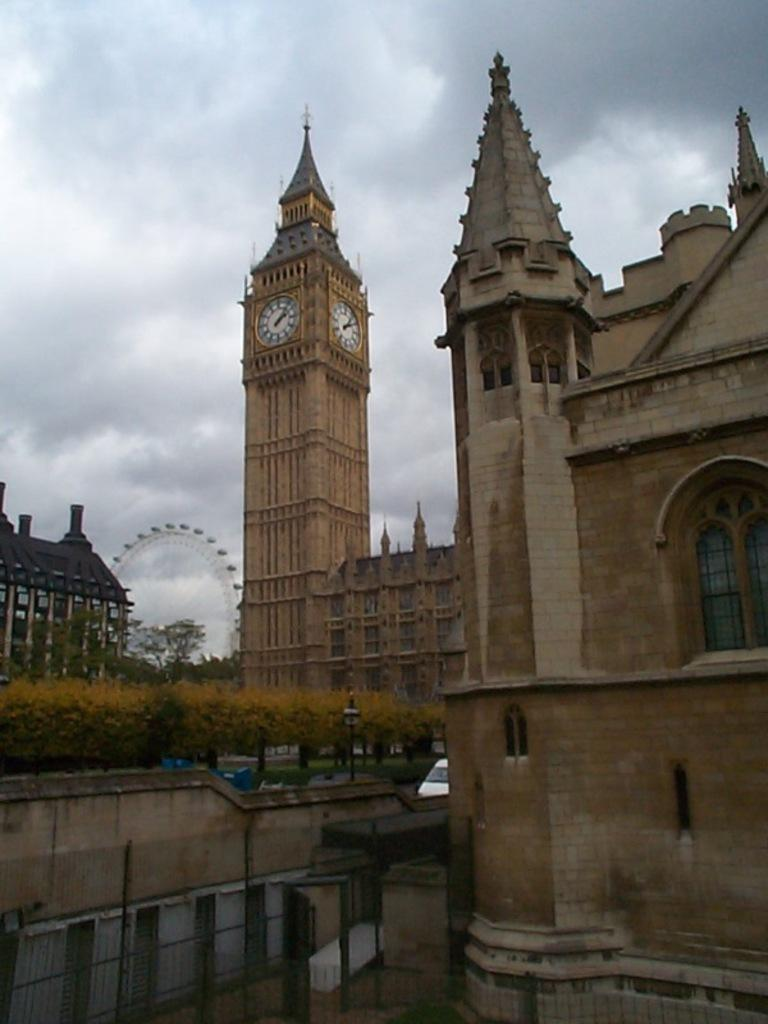What type of structures can be seen in the image? There are buildings in the image, including a clock tower and a ferris wheel. What type of barrier is present in the image? There is fencing in the image. What type of vegetation is visible in the image? There are trees in the image. What can be seen in the background of the image? The sky is visible in the background of the image. What type of authority figure can be seen in the image? There is no authority figure present in the image. What is in the pocket of the person in the image? There is no person or pocket visible in the image. 